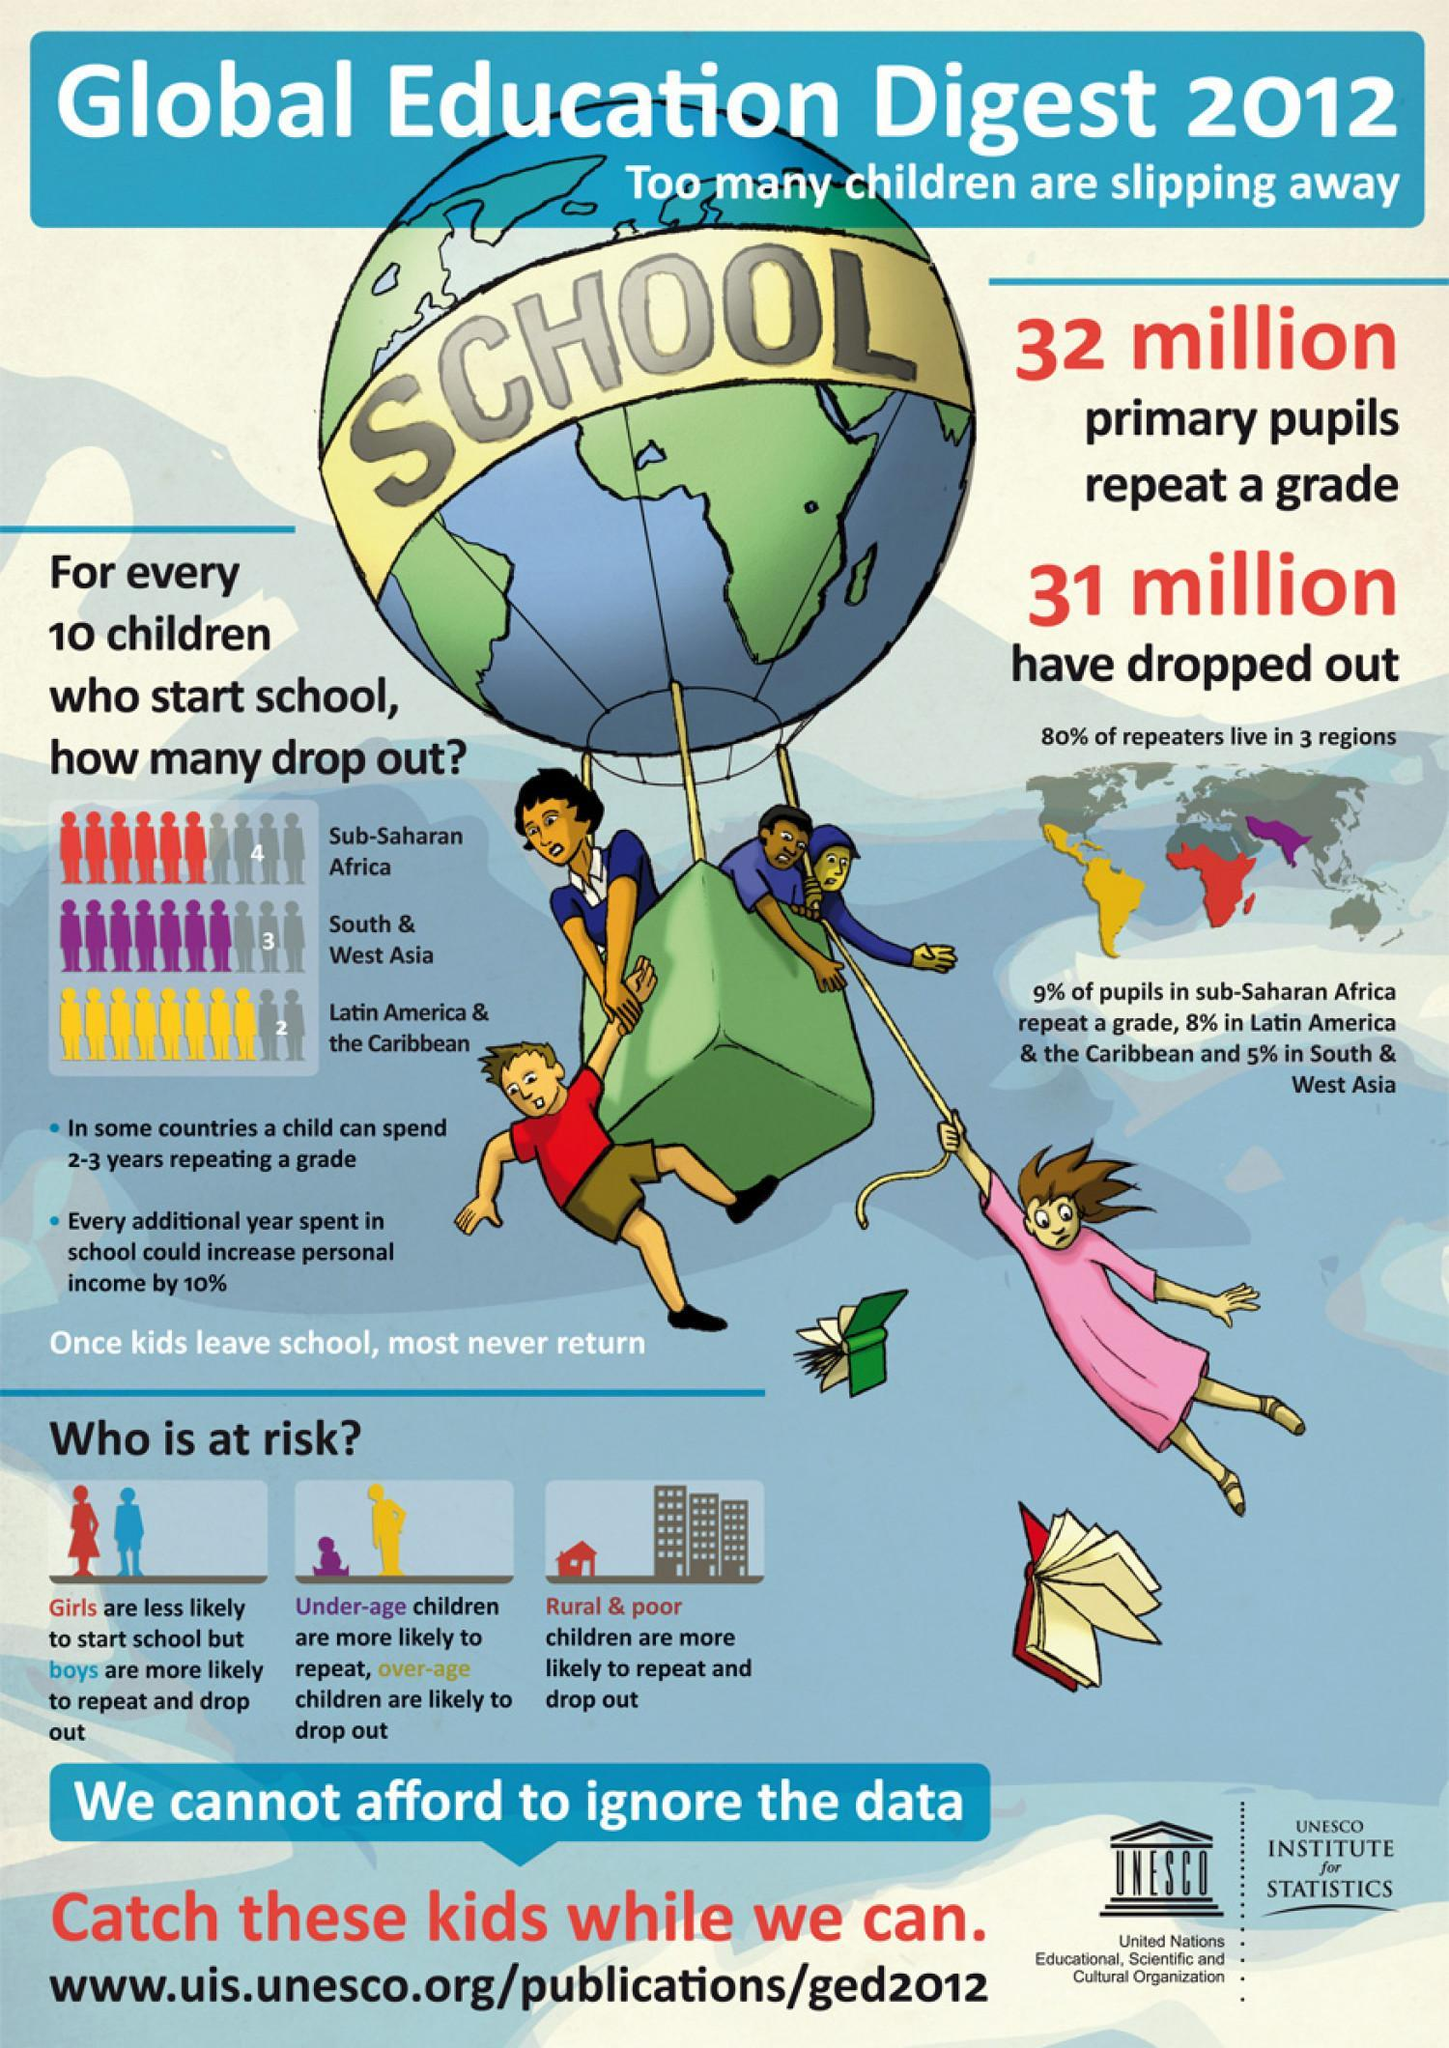Which region has the second lowest number of drop out for every ten students, Sub-Saharan Africa, South & West Asia, or Latin America & the Caribbean?
Answer the question with a short phrase. South & West Asia 